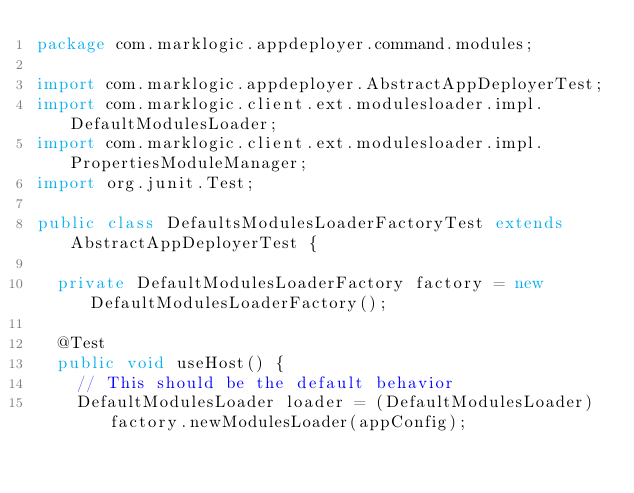<code> <loc_0><loc_0><loc_500><loc_500><_Java_>package com.marklogic.appdeployer.command.modules;

import com.marklogic.appdeployer.AbstractAppDeployerTest;
import com.marklogic.client.ext.modulesloader.impl.DefaultModulesLoader;
import com.marklogic.client.ext.modulesloader.impl.PropertiesModuleManager;
import org.junit.Test;

public class DefaultsModulesLoaderFactoryTest extends AbstractAppDeployerTest {

	private DefaultModulesLoaderFactory factory = new DefaultModulesLoaderFactory();

	@Test
	public void useHost() {
		// This should be the default behavior
		DefaultModulesLoader loader = (DefaultModulesLoader) factory.newModulesLoader(appConfig);</code> 